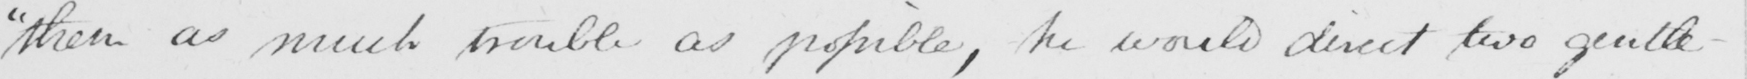What text is written in this handwritten line? " them as much trouble as possible , he would direct two gentle- 